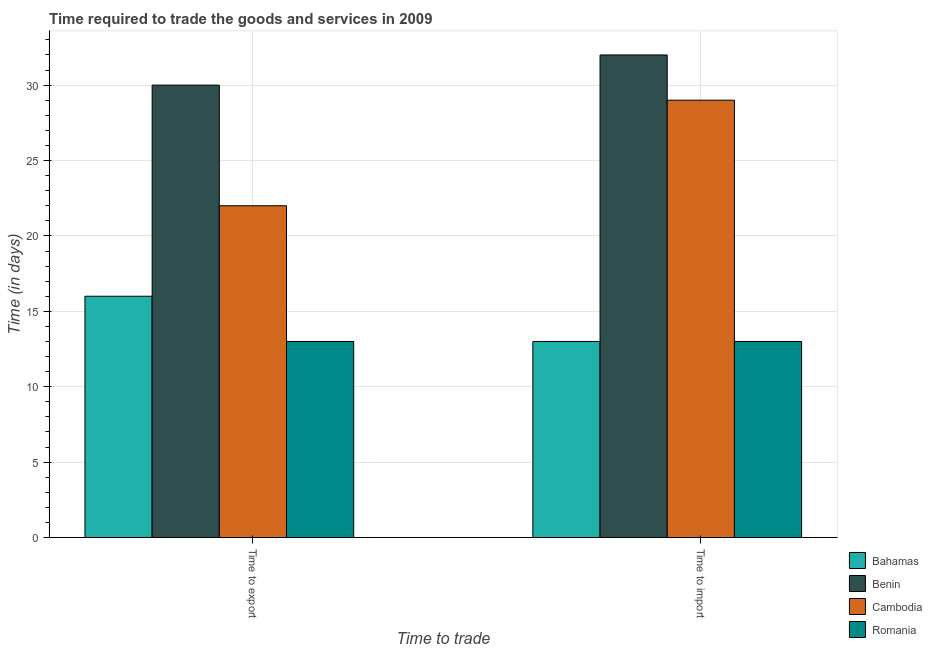How many different coloured bars are there?
Provide a succinct answer. 4. What is the label of the 2nd group of bars from the left?
Offer a very short reply. Time to import. What is the time to import in Romania?
Your answer should be very brief. 13. Across all countries, what is the maximum time to import?
Offer a terse response. 32. Across all countries, what is the minimum time to export?
Your response must be concise. 13. In which country was the time to import maximum?
Your answer should be compact. Benin. In which country was the time to import minimum?
Provide a short and direct response. Bahamas. What is the total time to import in the graph?
Ensure brevity in your answer.  87. What is the difference between the time to import in Benin and that in Romania?
Offer a terse response. 19. What is the difference between the time to import in Cambodia and the time to export in Bahamas?
Make the answer very short. 13. What is the average time to export per country?
Your response must be concise. 20.25. What is the difference between the time to import and time to export in Cambodia?
Offer a terse response. 7. What is the ratio of the time to export in Cambodia to that in Bahamas?
Your response must be concise. 1.38. Is the time to import in Benin less than that in Cambodia?
Offer a very short reply. No. What does the 3rd bar from the left in Time to export represents?
Give a very brief answer. Cambodia. What does the 3rd bar from the right in Time to export represents?
Your response must be concise. Benin. Are all the bars in the graph horizontal?
Your answer should be compact. No. What is the difference between two consecutive major ticks on the Y-axis?
Provide a short and direct response. 5. How are the legend labels stacked?
Ensure brevity in your answer.  Vertical. What is the title of the graph?
Provide a succinct answer. Time required to trade the goods and services in 2009. Does "Maldives" appear as one of the legend labels in the graph?
Your response must be concise. No. What is the label or title of the X-axis?
Keep it short and to the point. Time to trade. What is the label or title of the Y-axis?
Offer a very short reply. Time (in days). What is the Time (in days) in Bahamas in Time to export?
Keep it short and to the point. 16. What is the Time (in days) in Benin in Time to export?
Keep it short and to the point. 30. What is the Time (in days) of Cambodia in Time to export?
Give a very brief answer. 22. What is the Time (in days) of Bahamas in Time to import?
Offer a terse response. 13. What is the Time (in days) in Benin in Time to import?
Ensure brevity in your answer.  32. What is the Time (in days) in Cambodia in Time to import?
Offer a terse response. 29. What is the Time (in days) of Romania in Time to import?
Your response must be concise. 13. Across all Time to trade, what is the maximum Time (in days) in Bahamas?
Your response must be concise. 16. Across all Time to trade, what is the maximum Time (in days) in Romania?
Offer a very short reply. 13. Across all Time to trade, what is the minimum Time (in days) of Bahamas?
Make the answer very short. 13. Across all Time to trade, what is the minimum Time (in days) in Cambodia?
Your answer should be compact. 22. Across all Time to trade, what is the minimum Time (in days) of Romania?
Your answer should be compact. 13. What is the total Time (in days) of Benin in the graph?
Ensure brevity in your answer.  62. What is the difference between the Time (in days) in Bahamas in Time to export and that in Time to import?
Keep it short and to the point. 3. What is the difference between the Time (in days) in Benin in Time to export and that in Time to import?
Give a very brief answer. -2. What is the difference between the Time (in days) in Romania in Time to export and that in Time to import?
Make the answer very short. 0. What is the difference between the Time (in days) in Bahamas in Time to export and the Time (in days) in Benin in Time to import?
Your answer should be compact. -16. What is the difference between the Time (in days) in Bahamas in Time to export and the Time (in days) in Romania in Time to import?
Keep it short and to the point. 3. What is the difference between the Time (in days) in Benin in Time to export and the Time (in days) in Romania in Time to import?
Provide a short and direct response. 17. What is the difference between the Time (in days) in Cambodia in Time to export and the Time (in days) in Romania in Time to import?
Provide a succinct answer. 9. What is the difference between the Time (in days) of Bahamas and Time (in days) of Benin in Time to export?
Keep it short and to the point. -14. What is the difference between the Time (in days) of Bahamas and Time (in days) of Cambodia in Time to export?
Provide a succinct answer. -6. What is the difference between the Time (in days) in Bahamas and Time (in days) in Romania in Time to export?
Your answer should be very brief. 3. What is the difference between the Time (in days) in Benin and Time (in days) in Cambodia in Time to export?
Offer a very short reply. 8. What is the difference between the Time (in days) in Cambodia and Time (in days) in Romania in Time to export?
Give a very brief answer. 9. What is the difference between the Time (in days) in Bahamas and Time (in days) in Benin in Time to import?
Provide a short and direct response. -19. What is the difference between the Time (in days) of Bahamas and Time (in days) of Cambodia in Time to import?
Ensure brevity in your answer.  -16. What is the difference between the Time (in days) in Cambodia and Time (in days) in Romania in Time to import?
Provide a succinct answer. 16. What is the ratio of the Time (in days) of Bahamas in Time to export to that in Time to import?
Your response must be concise. 1.23. What is the ratio of the Time (in days) of Benin in Time to export to that in Time to import?
Ensure brevity in your answer.  0.94. What is the ratio of the Time (in days) in Cambodia in Time to export to that in Time to import?
Your answer should be very brief. 0.76. What is the ratio of the Time (in days) in Romania in Time to export to that in Time to import?
Your answer should be compact. 1. What is the difference between the highest and the second highest Time (in days) of Bahamas?
Your answer should be very brief. 3. What is the difference between the highest and the second highest Time (in days) in Benin?
Keep it short and to the point. 2. What is the difference between the highest and the lowest Time (in days) of Bahamas?
Offer a very short reply. 3. What is the difference between the highest and the lowest Time (in days) of Benin?
Your response must be concise. 2. What is the difference between the highest and the lowest Time (in days) of Romania?
Your answer should be very brief. 0. 